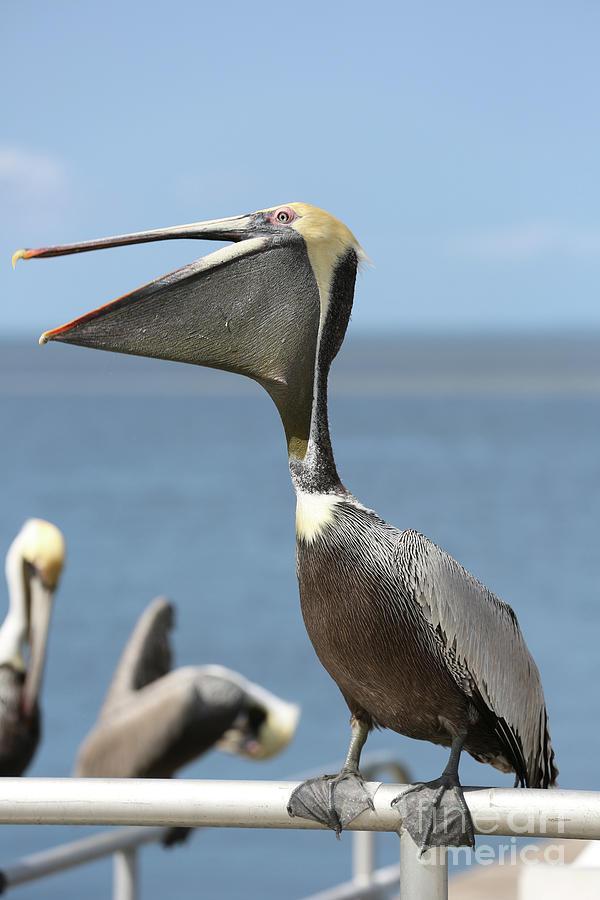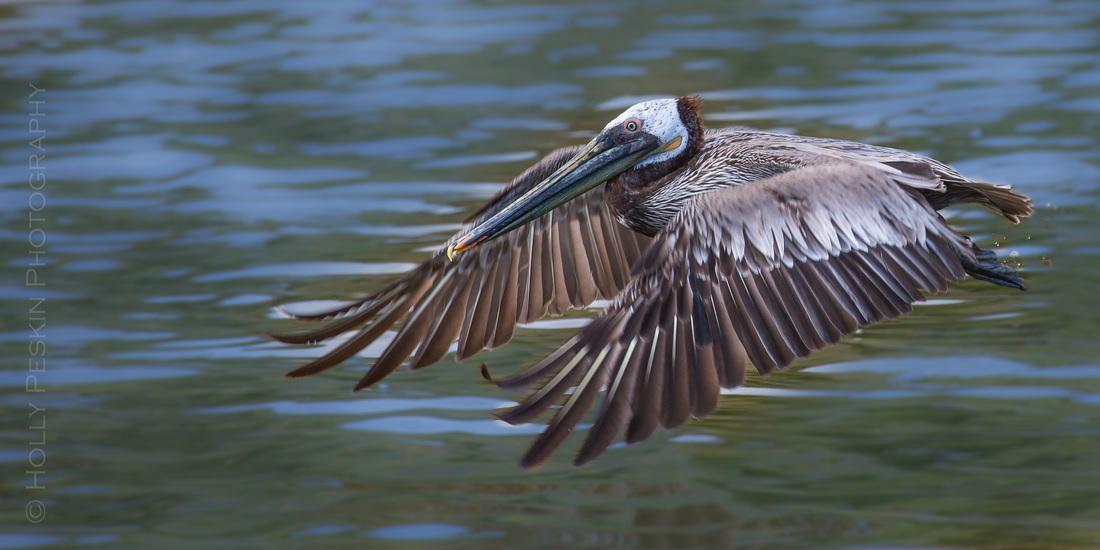The first image is the image on the left, the second image is the image on the right. For the images shown, is this caption "All of the pelicans are swimming." true? Answer yes or no. No. The first image is the image on the left, the second image is the image on the right. Analyze the images presented: Is the assertion "The birds in both images are swimming." valid? Answer yes or no. No. 